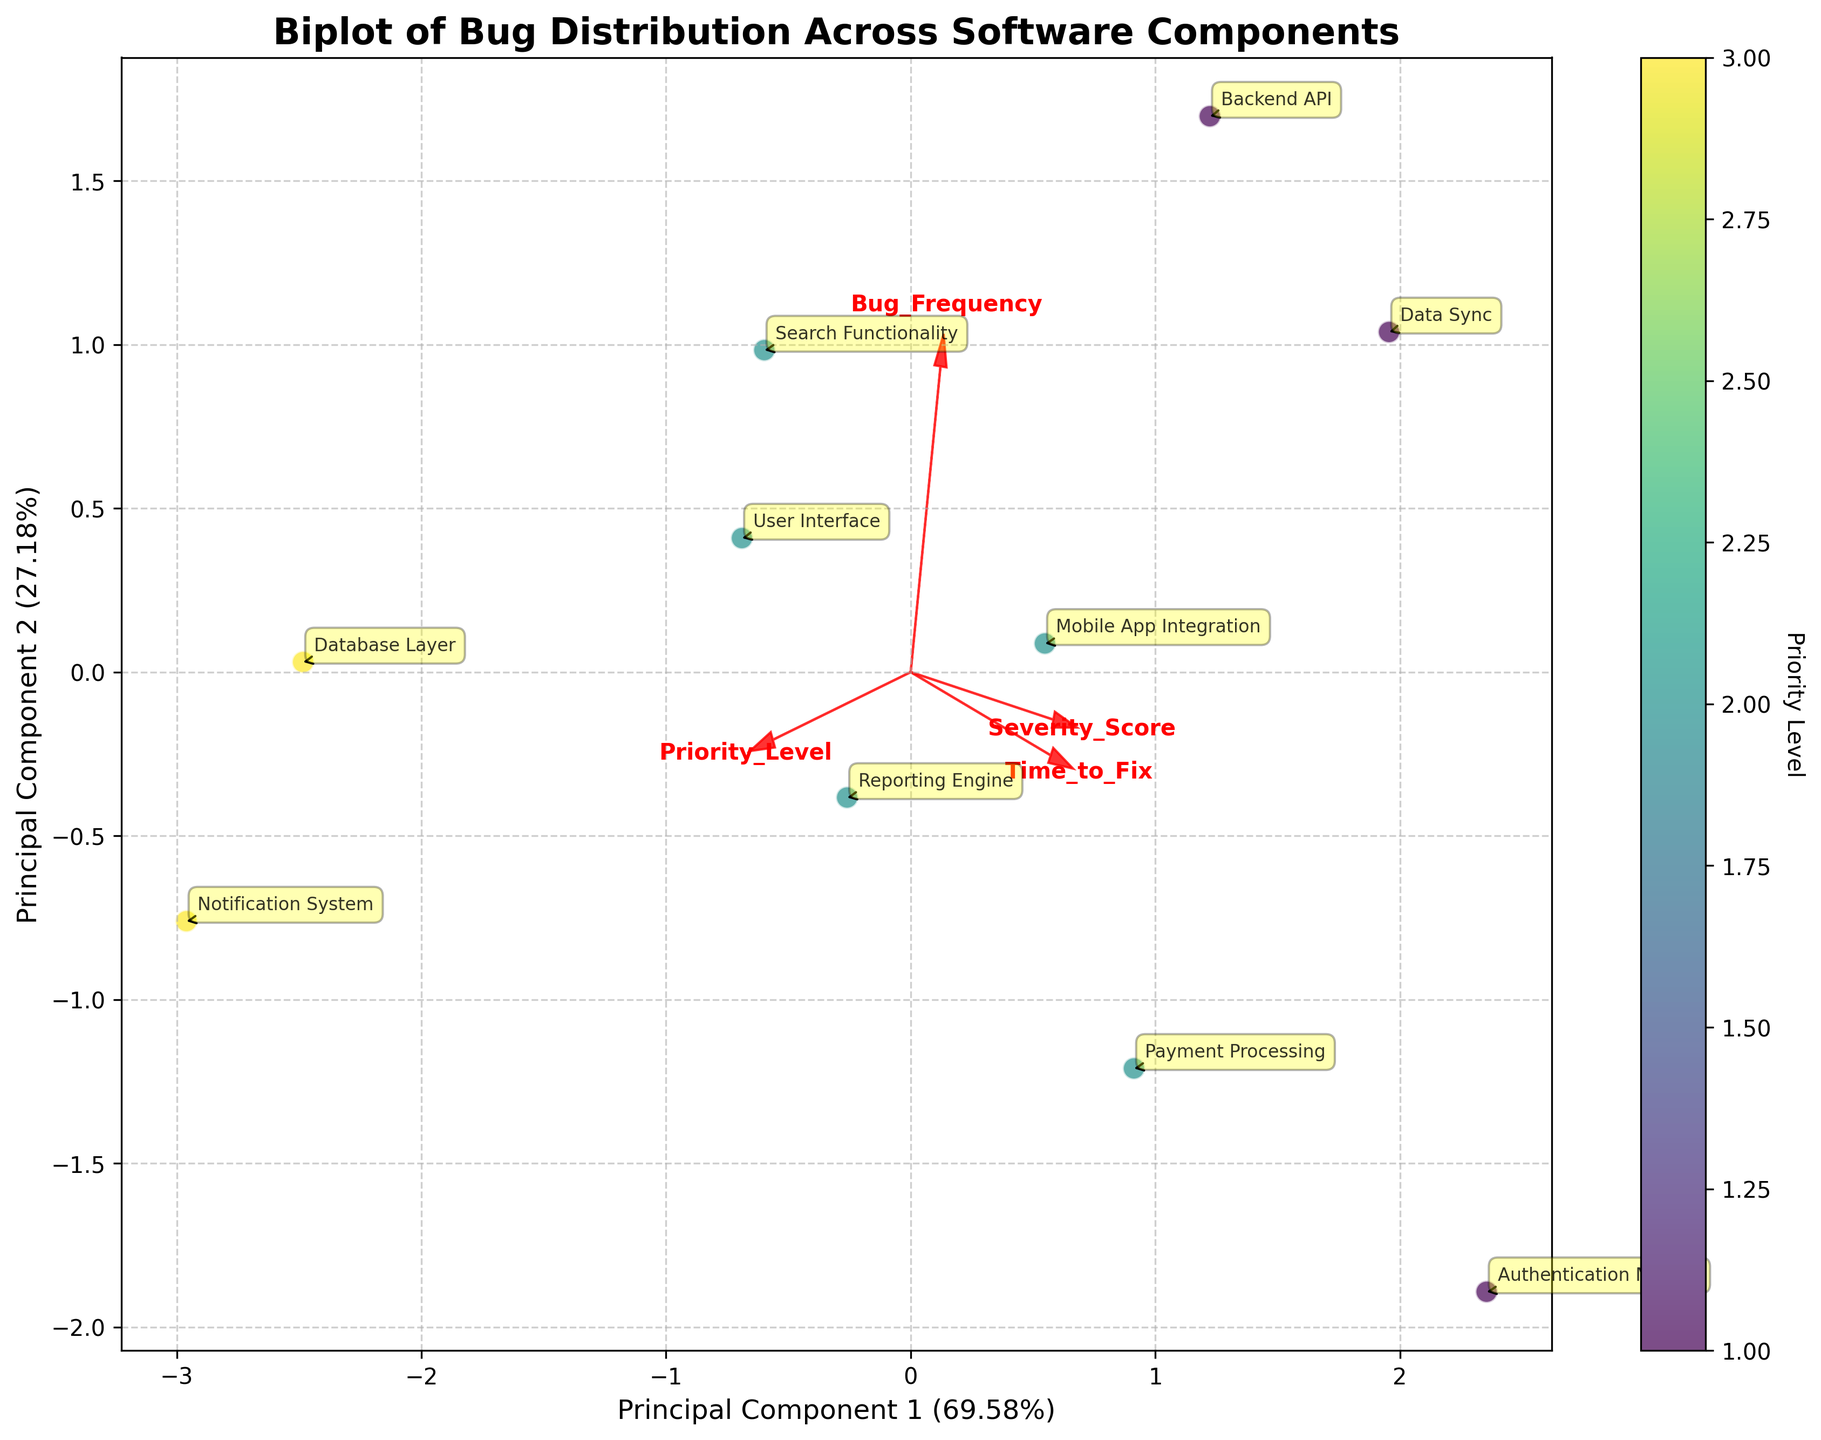What's the title of this figure? The title of the figure is usually placed at the top in a larger font. In this case, looking at the top of the figure, we can see the title "Biplot of Bug Distribution Across Software Components."
Answer: Biplot of Bug Distribution Across Software Components What's the colorbar label indicate? The colorbar label can be read to the right of the color gradient bar. In this figure, it reads "Priority Level," indicating that the colors represent the priority levels of the components.
Answer: Priority Level Which component has the highest Bug Frequency? Each component is labeled near its corresponding point in the scatter plot. By examining the plot, the "Backend API" is positioned the highest along the Principal Component that correlates most strongly with Bug Frequency.
Answer: Backend API How many components have a Priority Level of 1? The color of the points indicates the Priority Level. Points colored with the same shade in the 'viridis' color map represent the same Priority Level. Looking closely, there are four such points corresponding to "Backend API," "Authentication Module," "Data Sync," and none other.
Answer: 4 How is the Severity Score related to the Time to Fix? Feature vectors ('arrows') point in directions that correlate with these features. If the arrows for Severity Score and Time to Fix point in similar directions, they are positively correlated. Observing the plot, both arrows point in approximately similar directions, indicating a positive correlation.
Answer: Positively correlated Which component has the lowest Severity Score? Look at the points on the scatter plot and their annotations for severity. By examining the axes, the "Notification System" component is positioned lowest along the axis most correlated with Severity Score.
Answer: Notification System What components cluster closely together in terms of principal components? Look at points that are near each other in the scatter plot. Components that are close to each other will have points near each other. The "User Interface" and "Search Functionality" appear to be very close.
Answer: User Interface and Search Functionality Among the components with a Priority Level of 3, which one has the highest Bug Frequency? Locate the points with the color representing Priority Level 3 (using the colorbar) and then note which one of those points is highest along the Bug Frequency-related principal component. "Database Layer" is the only component at Level 3, so it has the highest frequency among them by default.
Answer: Database Layer Is Bug Frequency more aligned with Principal Component 1 or Principal Component 2? Examine the direction of the Bug Frequency arrow in relation to the axes representing the principal components. The Bug Frequency arrow points more sharply towards Principal Component 1, highlighting a stronger alignment.
Answer: Principal Component 1 